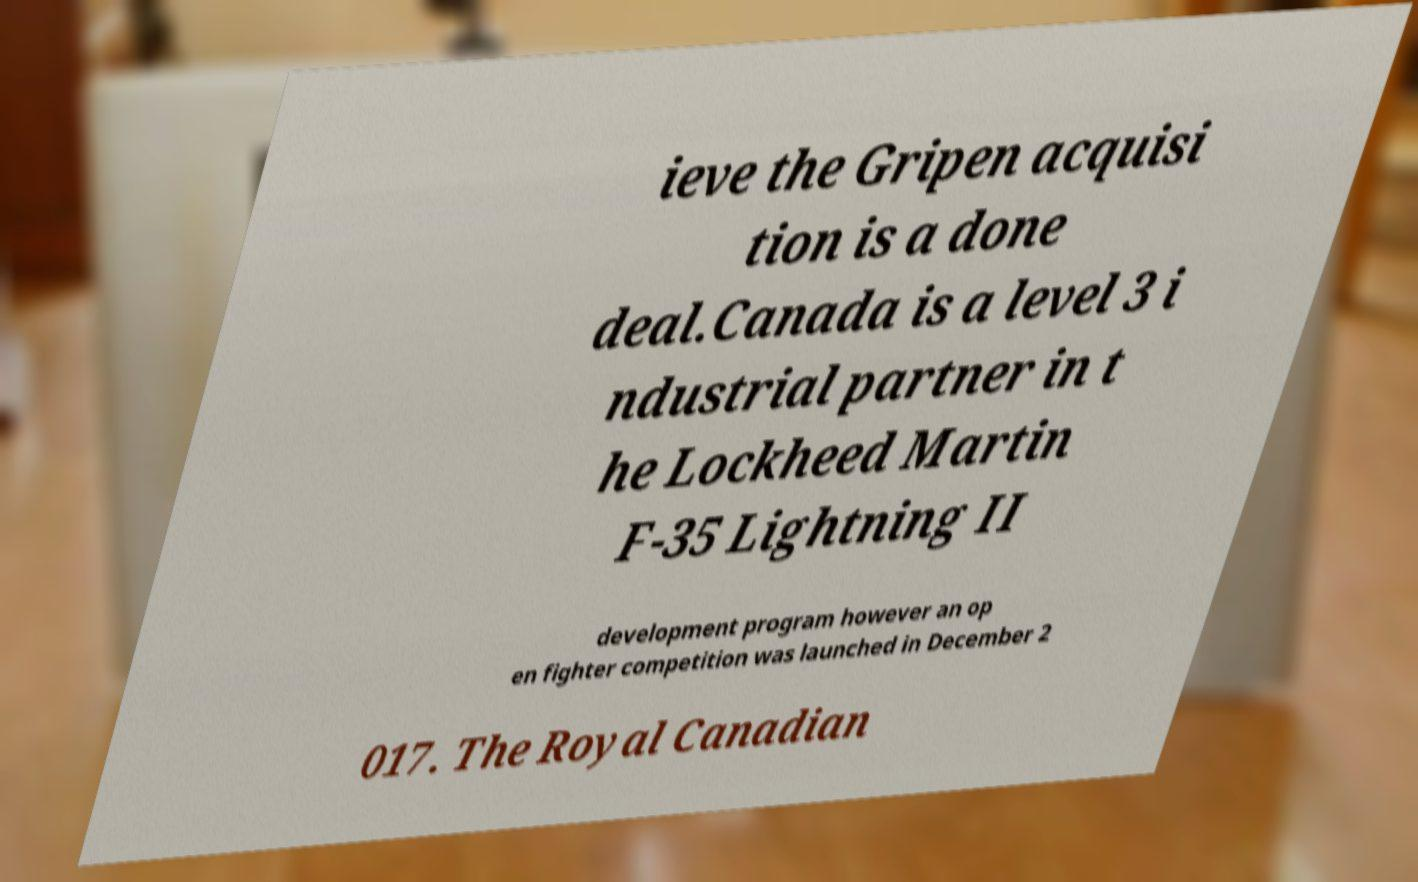Could you assist in decoding the text presented in this image and type it out clearly? ieve the Gripen acquisi tion is a done deal.Canada is a level 3 i ndustrial partner in t he Lockheed Martin F-35 Lightning II development program however an op en fighter competition was launched in December 2 017. The Royal Canadian 